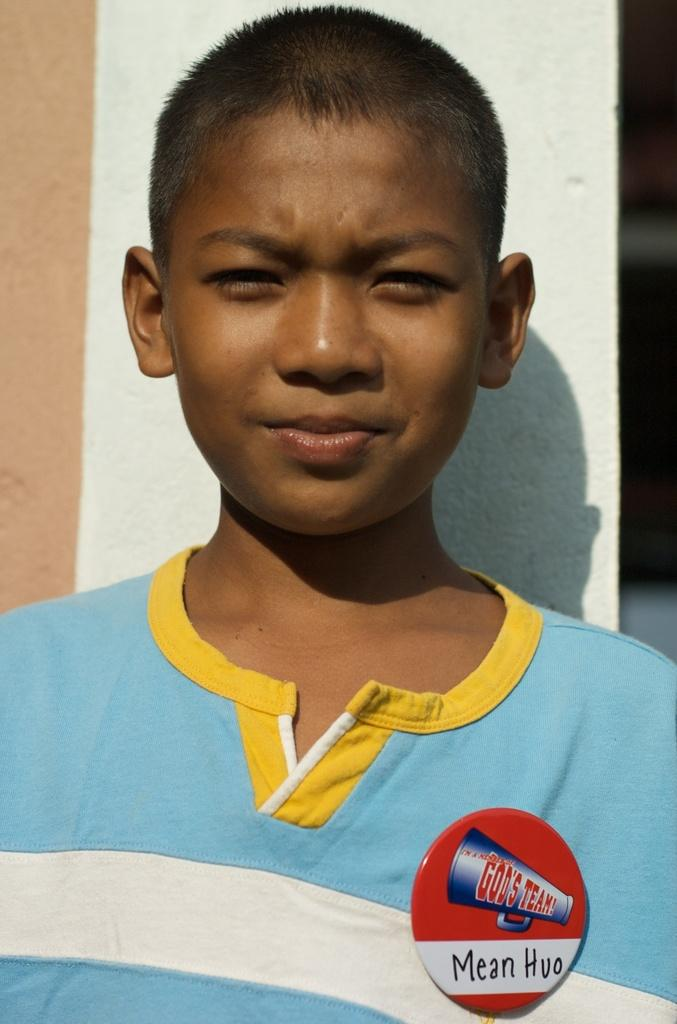What is the main subject of the image? The main subject of the image is a small boy. What is the boy wearing? The boy is wearing a blue t-shirt. What is the boy's facial expression in the image? The boy is smiling. What is the boy doing in the image? The boy is giving a pose into the camera. What can be seen in the background of the image? There is a white color wall in the background of the image. What is the expert arguing about with the boy in the image? There is no expert or argument present in the image; it features a small boy smiling and posing for the camera. 